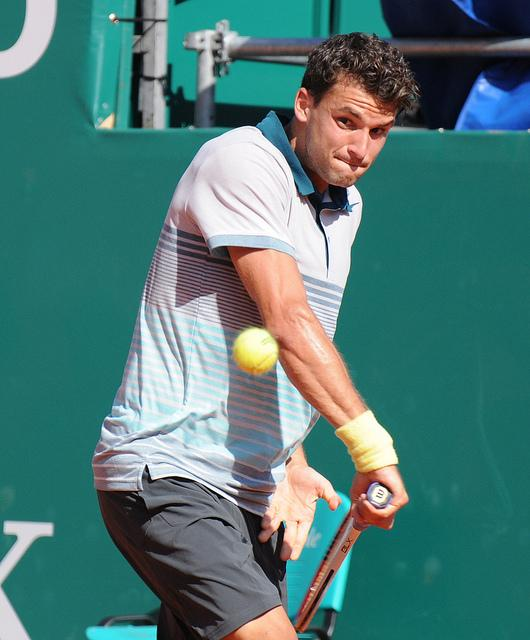What technique does this player utilize here? backhand 